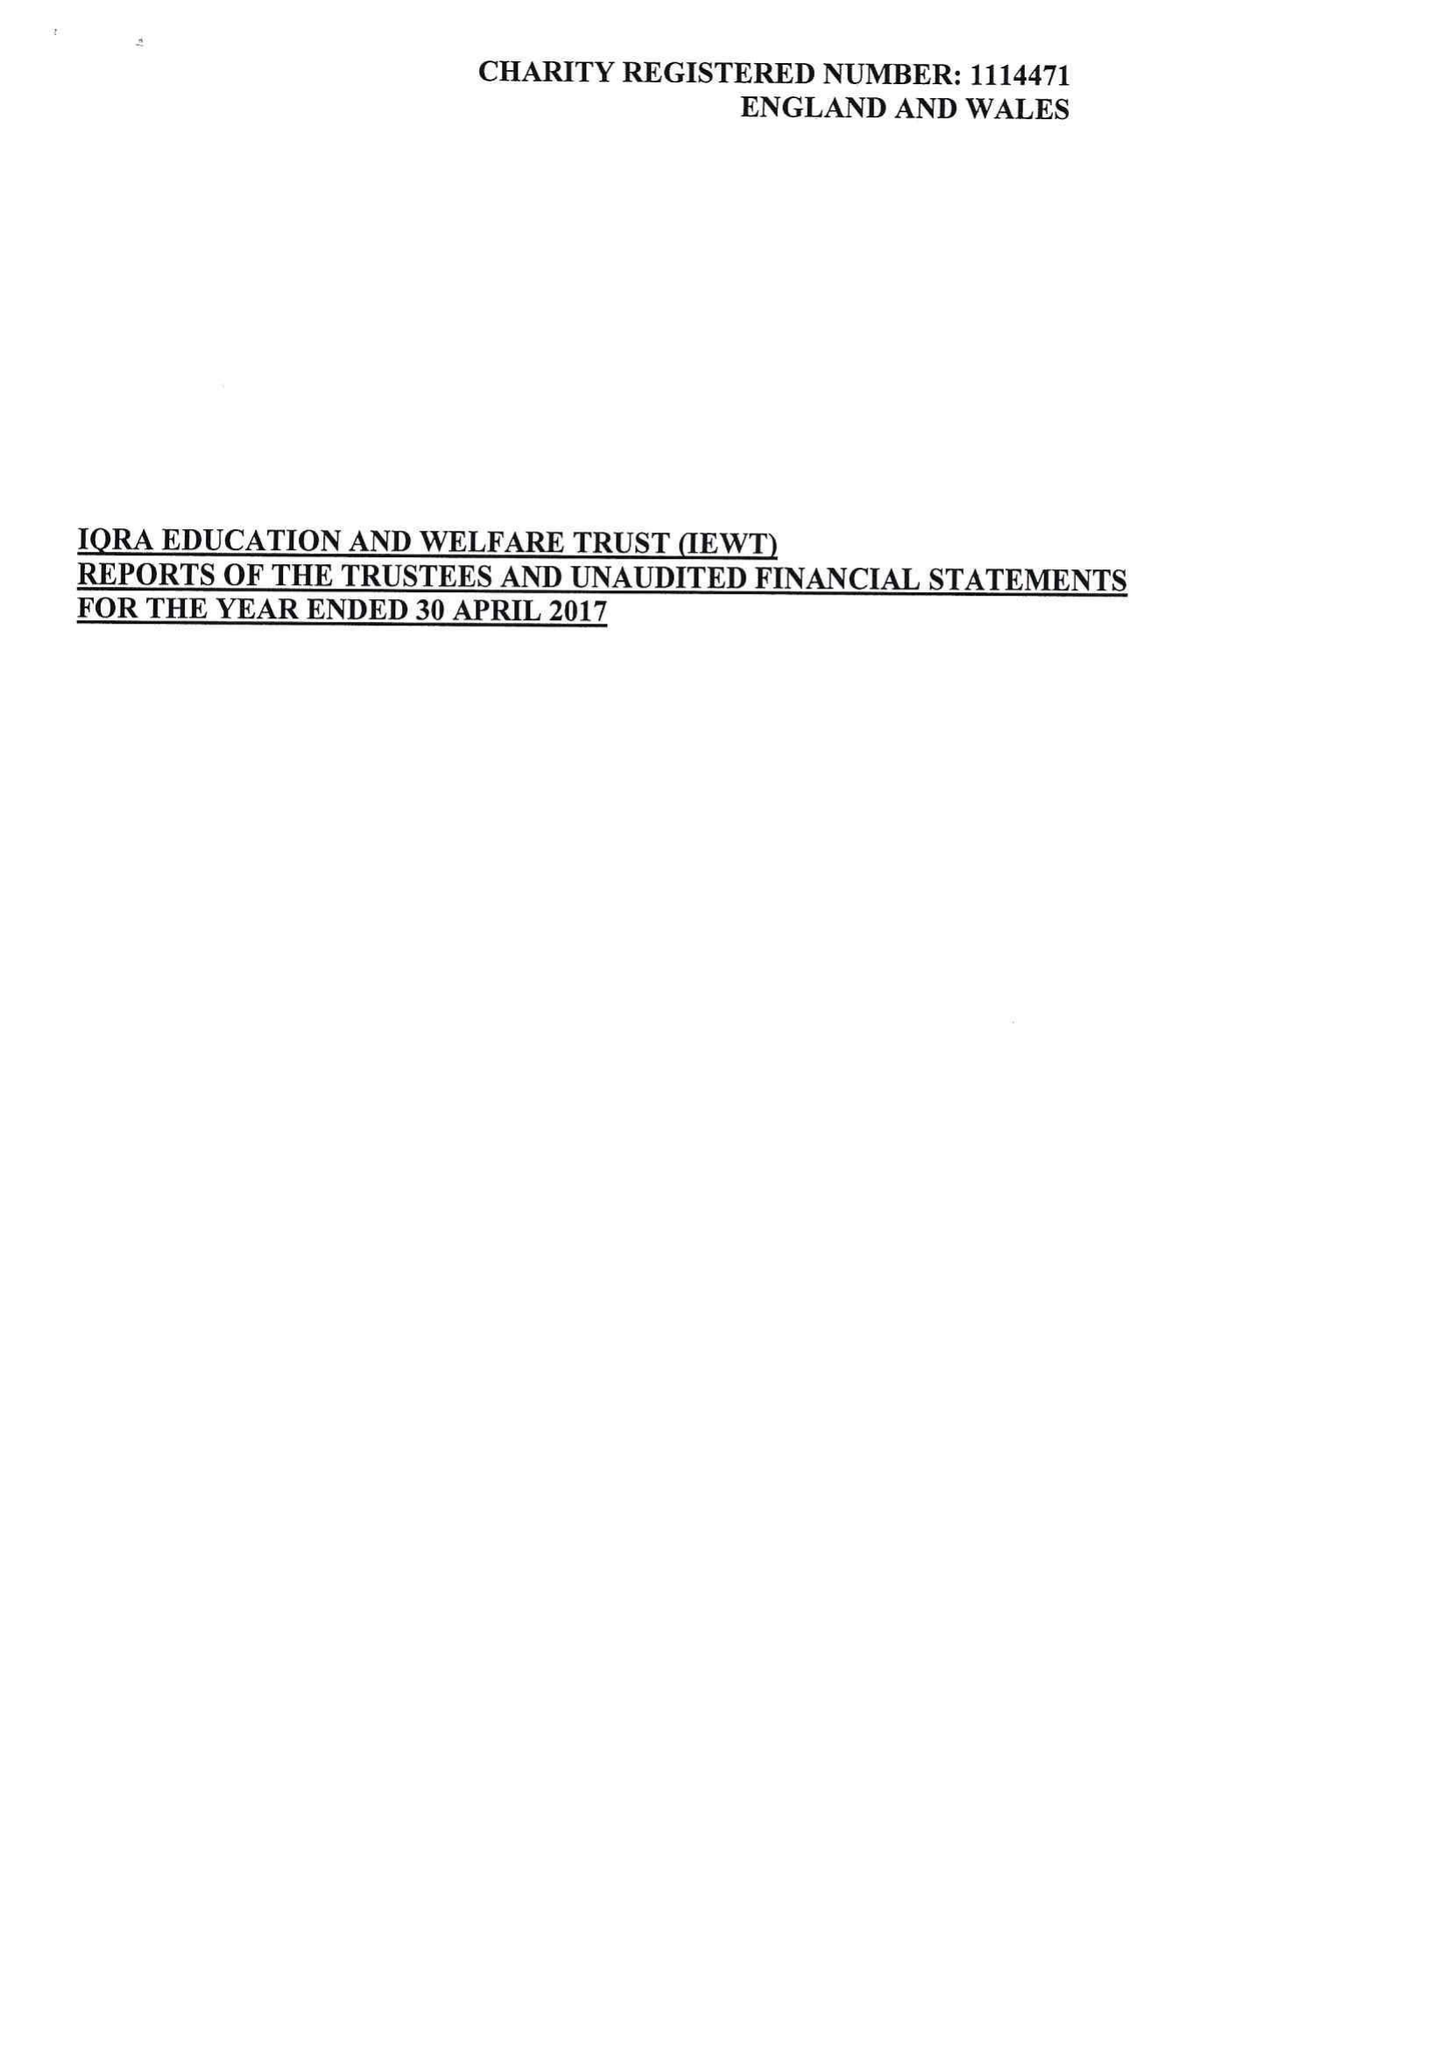What is the value for the address__postcode?
Answer the question using a single word or phrase. OL4 1ER 